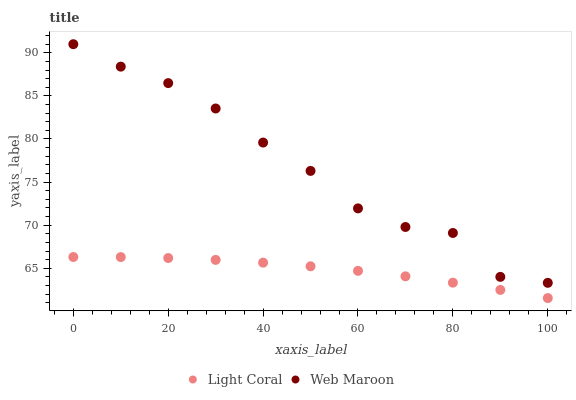Does Light Coral have the minimum area under the curve?
Answer yes or no. Yes. Does Web Maroon have the maximum area under the curve?
Answer yes or no. Yes. Does Web Maroon have the minimum area under the curve?
Answer yes or no. No. Is Light Coral the smoothest?
Answer yes or no. Yes. Is Web Maroon the roughest?
Answer yes or no. Yes. Is Web Maroon the smoothest?
Answer yes or no. No. Does Light Coral have the lowest value?
Answer yes or no. Yes. Does Web Maroon have the lowest value?
Answer yes or no. No. Does Web Maroon have the highest value?
Answer yes or no. Yes. Is Light Coral less than Web Maroon?
Answer yes or no. Yes. Is Web Maroon greater than Light Coral?
Answer yes or no. Yes. Does Light Coral intersect Web Maroon?
Answer yes or no. No. 